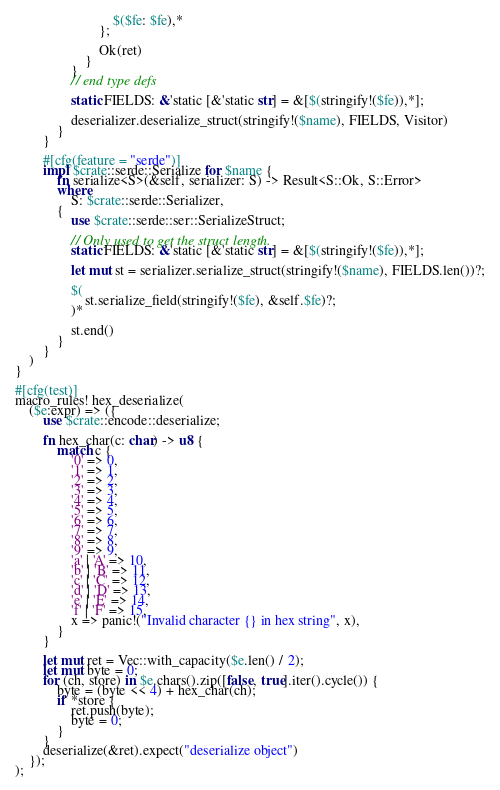<code> <loc_0><loc_0><loc_500><loc_500><_Rust_>                            $($fe: $fe),*
                        };

                        Ok(ret)
                    }
                }
                // end type defs

                static FIELDS: &'static [&'static str] = &[$(stringify!($fe)),*];

                deserializer.deserialize_struct(stringify!($name), FIELDS, Visitor)
            }
        }

        #[cfg(feature = "serde")]
        impl $crate::serde::Serialize for $name {
            fn serialize<S>(&self, serializer: S) -> Result<S::Ok, S::Error>
            where
                S: $crate::serde::Serializer,
            {
                use $crate::serde::ser::SerializeStruct;

                // Only used to get the struct length.
                static FIELDS: &'static [&'static str] = &[$(stringify!($fe)),*];

                let mut st = serializer.serialize_struct(stringify!($name), FIELDS.len())?;

                $(
                    st.serialize_field(stringify!($fe), &self.$fe)?;
                )*

                st.end()
            }
        }
    )
}

#[cfg(test)]
macro_rules! hex_deserialize(
    ($e:expr) => ({
        use $crate::encode::deserialize;

        fn hex_char(c: char) -> u8 {
            match c {
                '0' => 0,
                '1' => 1,
                '2' => 2,
                '3' => 3,
                '4' => 4,
                '5' => 5,
                '6' => 6,
                '7' => 7,
                '8' => 8,
                '9' => 9,
                'a' | 'A' => 10,
                'b' | 'B' => 11,
                'c' | 'C' => 12,
                'd' | 'D' => 13,
                'e' | 'E' => 14,
                'f' | 'F' => 15,
                x => panic!("Invalid character {} in hex string", x),
            }
        }

        let mut ret = Vec::with_capacity($e.len() / 2);
        let mut byte = 0;
        for (ch, store) in $e.chars().zip([false, true].iter().cycle()) {
            byte = (byte << 4) + hex_char(ch);
            if *store {
                ret.push(byte);
                byte = 0;
            }
        }
        deserialize(&ret).expect("deserialize object")
    });
);

</code> 